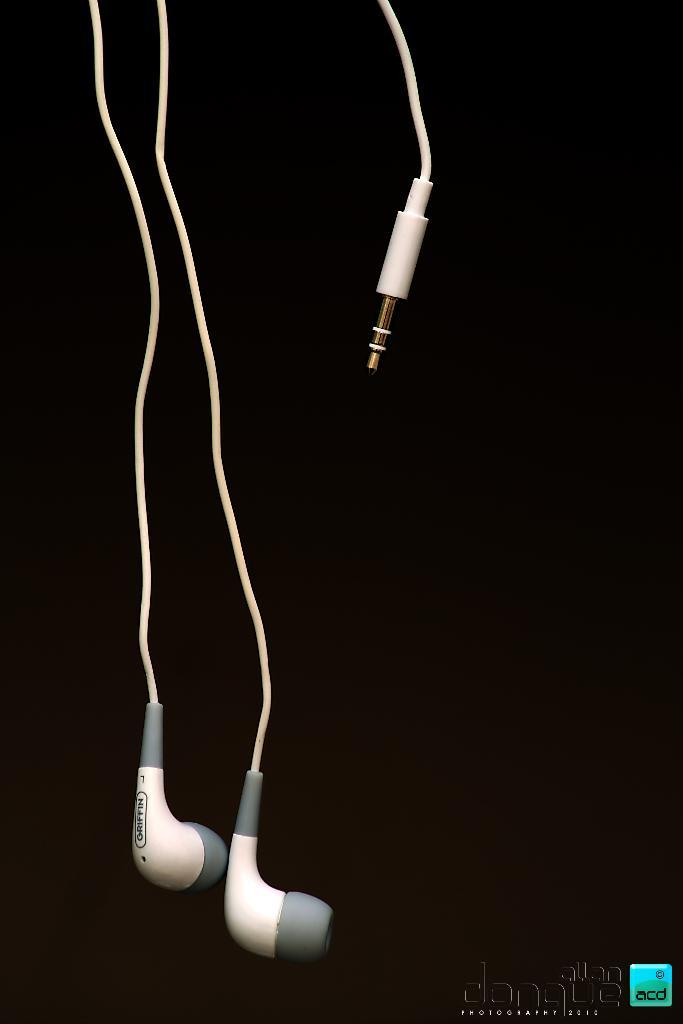What type of audio equipment is visible in the image? There are headphones in the image. Is there any text present in the image? Yes, there is some text at the bottom of the image. What type of stick can be seen supporting the basket in the image? There is no basket or stick present in the image. 